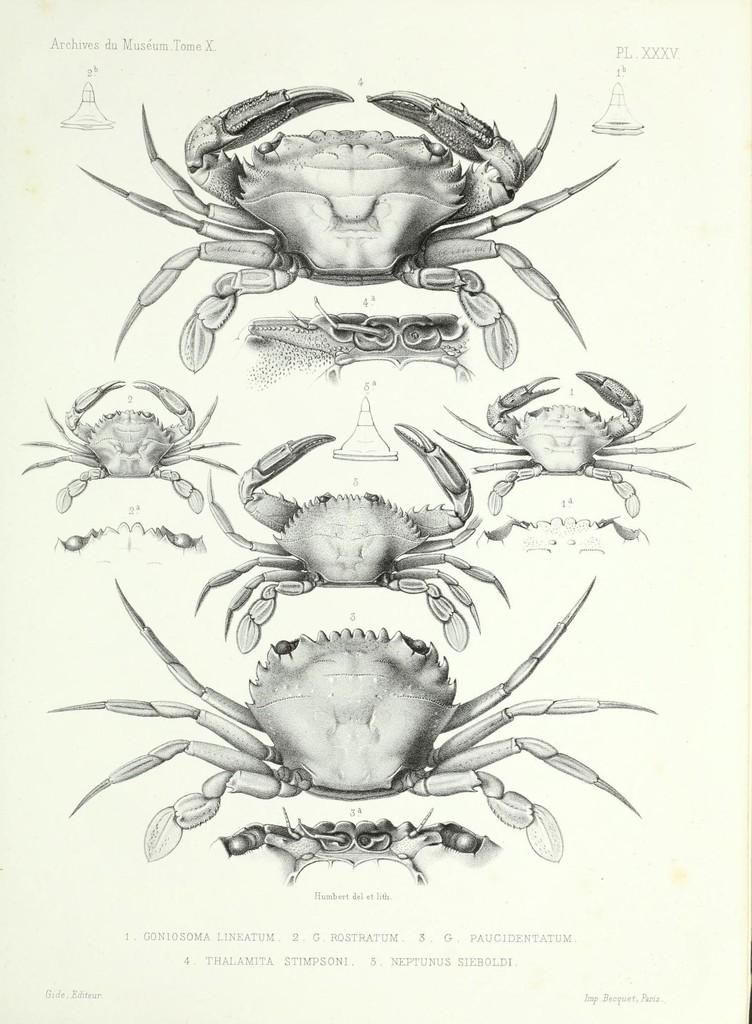What is the color of the paper in the image? The paper in the image is white. What is depicted on the white paper? There are scorpions on the paper. What type of tax is being discussed on the paper in the image? There is no mention of tax or any discussion on the paper in the image; it only features scorpions. 